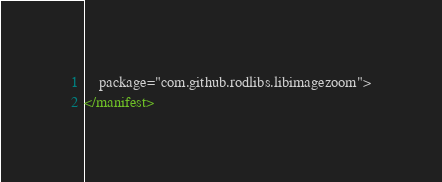<code> <loc_0><loc_0><loc_500><loc_500><_XML_>    package="com.github.rodlibs.libimagezoom">
</manifest></code> 